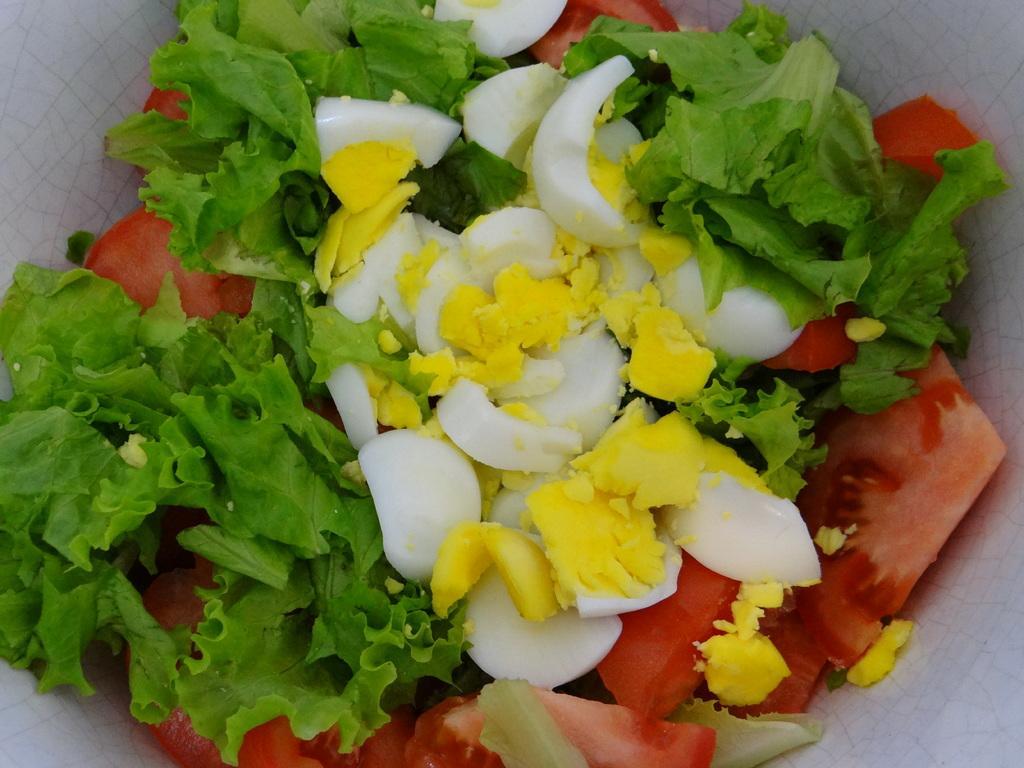Describe this image in one or two sentences. In this image there are crushed egg, pieces of tomato and vegetable leaves visible in the bowl. 